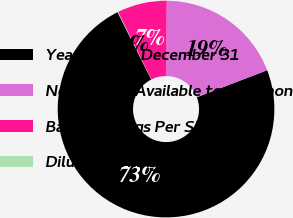Convert chart to OTSL. <chart><loc_0><loc_0><loc_500><loc_500><pie_chart><fcel>Years Ended December 31<fcel>Net Income Available to Common<fcel>Basic Earnings Per Share<fcel>Diluted Earnings Per Share<nl><fcel>73.46%<fcel>19.07%<fcel>7.41%<fcel>0.07%<nl></chart> 